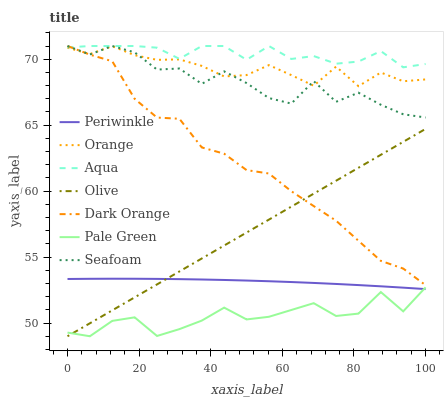Does Pale Green have the minimum area under the curve?
Answer yes or no. Yes. Does Aqua have the maximum area under the curve?
Answer yes or no. Yes. Does Seafoam have the minimum area under the curve?
Answer yes or no. No. Does Seafoam have the maximum area under the curve?
Answer yes or no. No. Is Olive the smoothest?
Answer yes or no. Yes. Is Seafoam the roughest?
Answer yes or no. Yes. Is Aqua the smoothest?
Answer yes or no. No. Is Aqua the roughest?
Answer yes or no. No. Does Olive have the lowest value?
Answer yes or no. Yes. Does Seafoam have the lowest value?
Answer yes or no. No. Does Seafoam have the highest value?
Answer yes or no. Yes. Does Olive have the highest value?
Answer yes or no. No. Is Periwinkle less than Aqua?
Answer yes or no. Yes. Is Dark Orange greater than Pale Green?
Answer yes or no. Yes. Does Periwinkle intersect Pale Green?
Answer yes or no. Yes. Is Periwinkle less than Pale Green?
Answer yes or no. No. Is Periwinkle greater than Pale Green?
Answer yes or no. No. Does Periwinkle intersect Aqua?
Answer yes or no. No. 